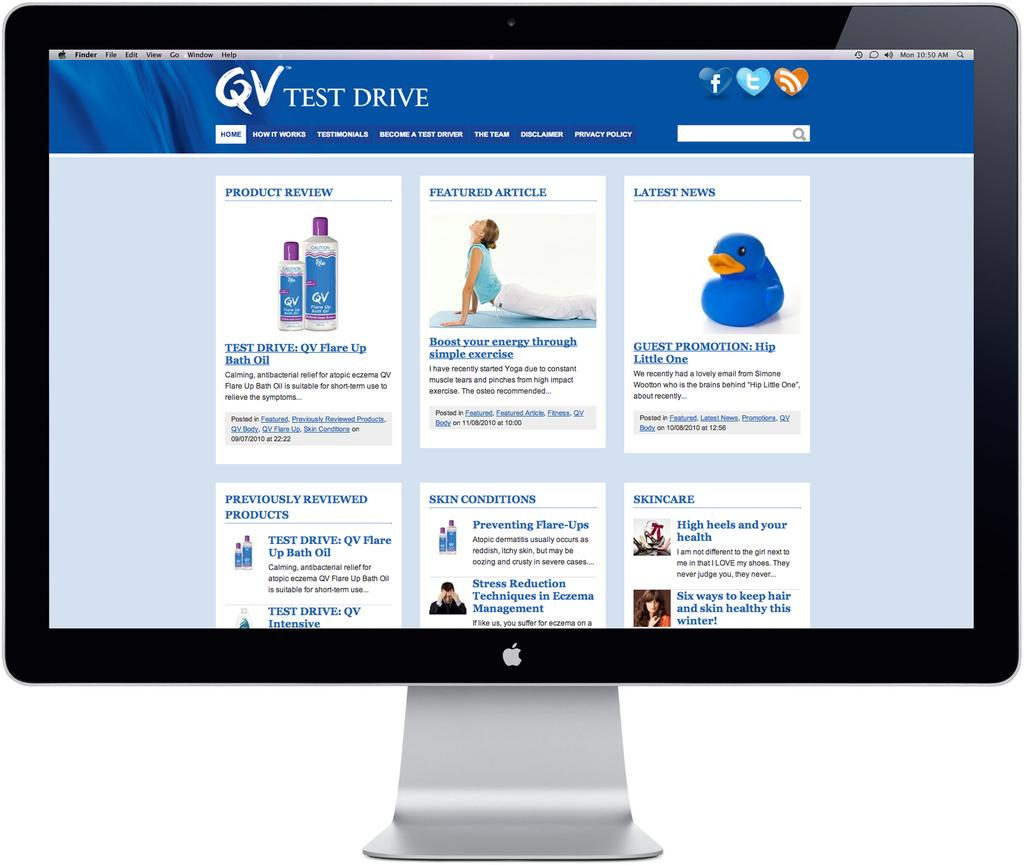<image>
Share a concise interpretation of the image provided. a mac screen open to the site for QV test drive 